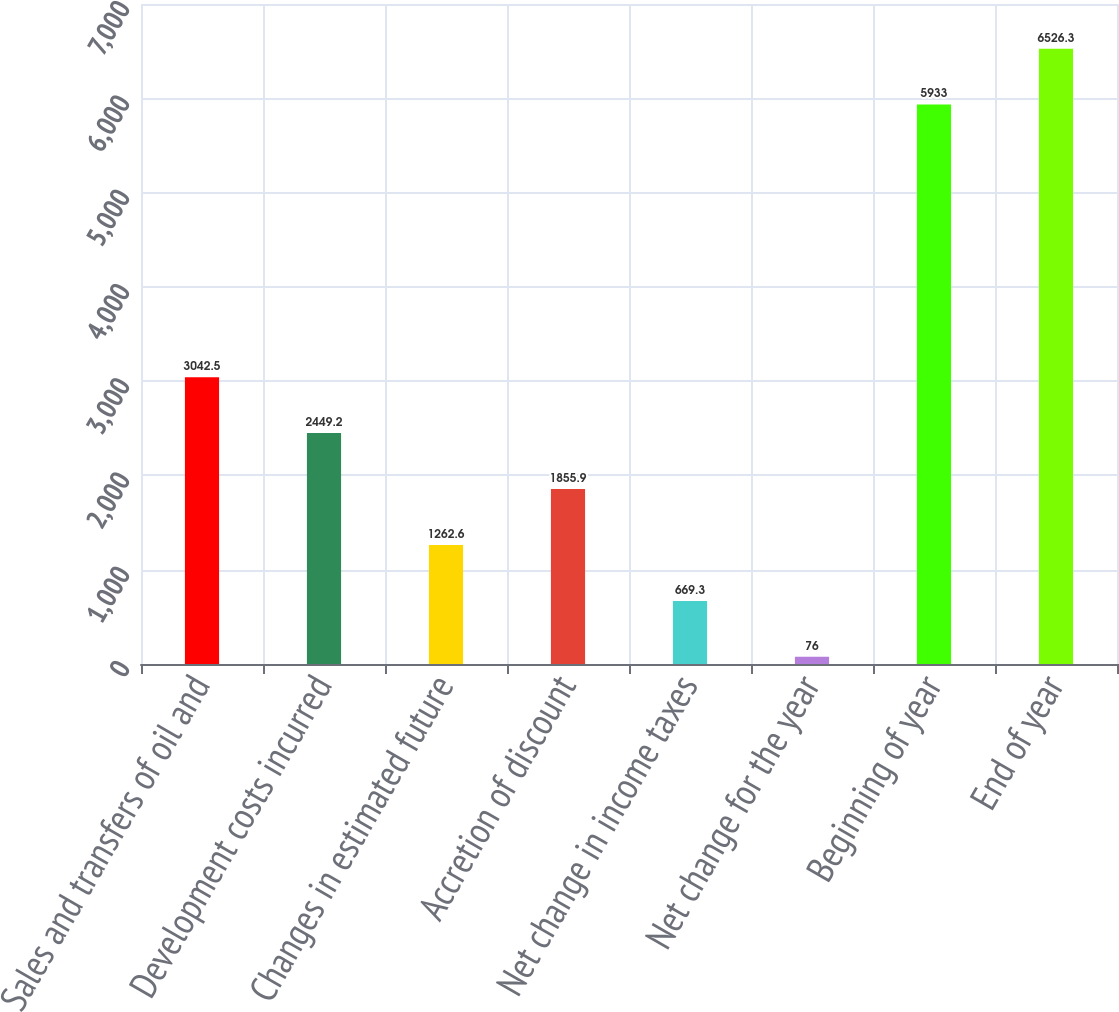<chart> <loc_0><loc_0><loc_500><loc_500><bar_chart><fcel>Sales and transfers of oil and<fcel>Development costs incurred<fcel>Changes in estimated future<fcel>Accretion of discount<fcel>Net change in income taxes<fcel>Net change for the year<fcel>Beginning of year<fcel>End of year<nl><fcel>3042.5<fcel>2449.2<fcel>1262.6<fcel>1855.9<fcel>669.3<fcel>76<fcel>5933<fcel>6526.3<nl></chart> 